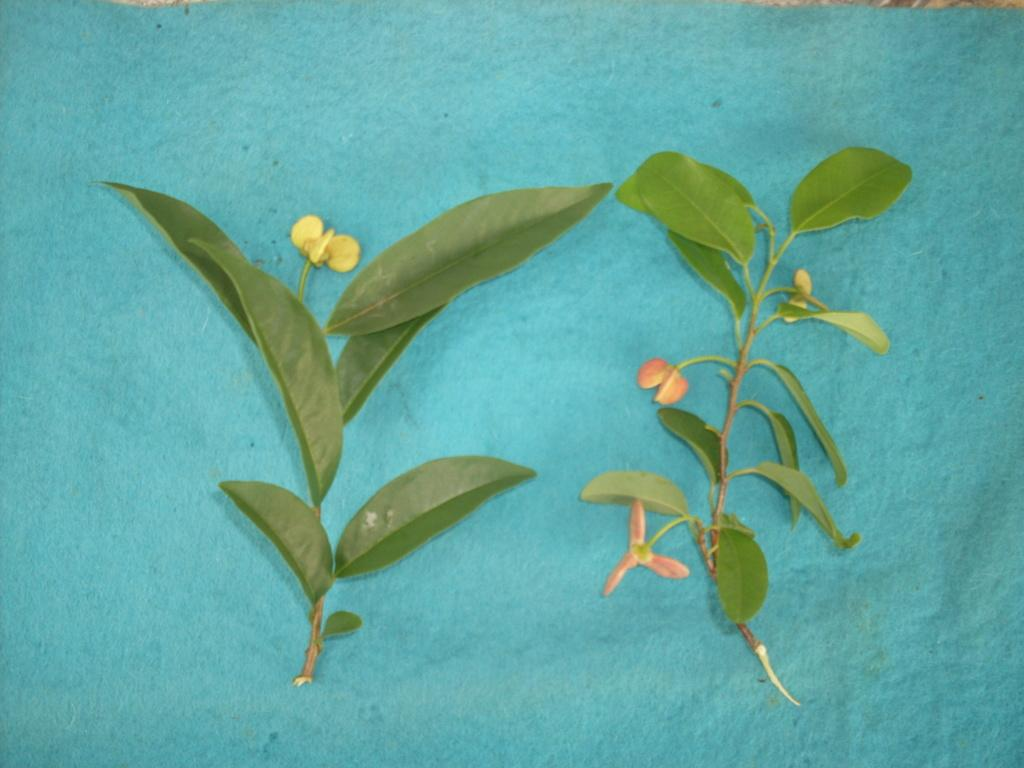What type of vegetation can be seen in the image? There are green leaves and flowers in the image. What color are the leaves in the image? The leaves in the image are green. What color is the surface in the image? The surface is blue. What type of cushion is being worn by the person in the image? There is no person or cushion present in the image; it features green leaves, flowers, and a blue surface. 